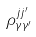<formula> <loc_0><loc_0><loc_500><loc_500>\rho _ { \gamma \gamma ^ { \prime } } ^ { j j ^ { \prime } }</formula> 